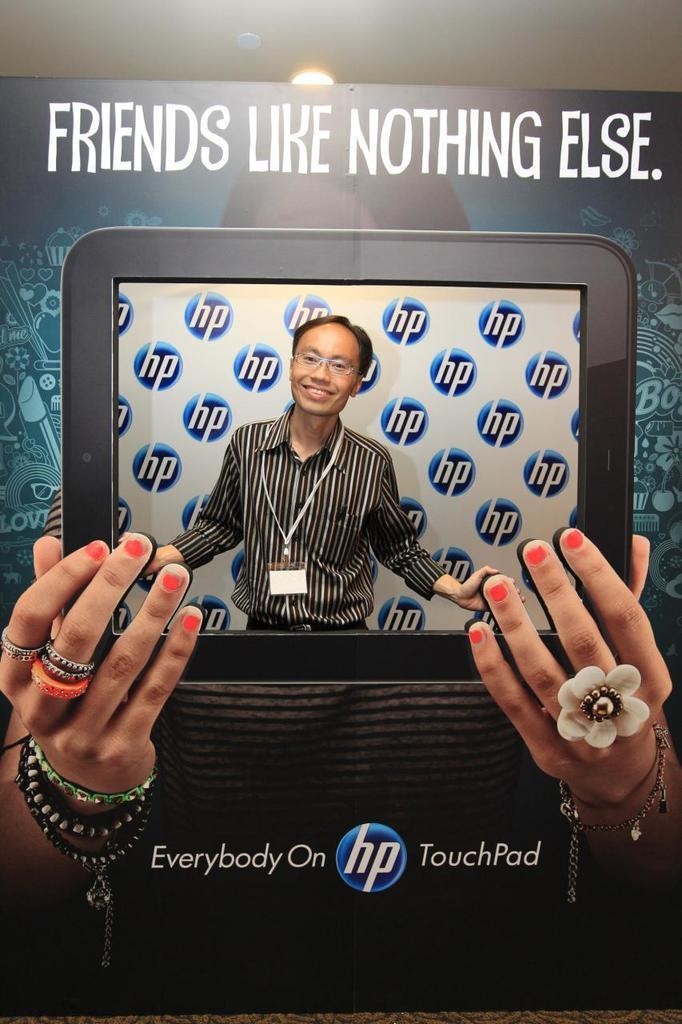What is the main subject of the image? The main subject of the image is a man. What is the man doing in the image? The man is standing in the image. What can be seen on the man's body? The man is wearing clothes, has an identity card, and is wearing spectacles. What type of image is this? The image is a poster. What other objects or elements are present in the image? There are two hands, a finger ring, a bracelet, text, and a light in the image. Can you tell me how many icicles are hanging from the man's chin in the image? There are no icicles present in the image, and the man's chin is not visible. What type of police uniform can be seen on the man in the image? The man is not depicted as a police officer, and there is no police uniform in the image. 